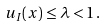Convert formula to latex. <formula><loc_0><loc_0><loc_500><loc_500>u _ { I } ( x ) \leq \lambda < 1 \, .</formula> 